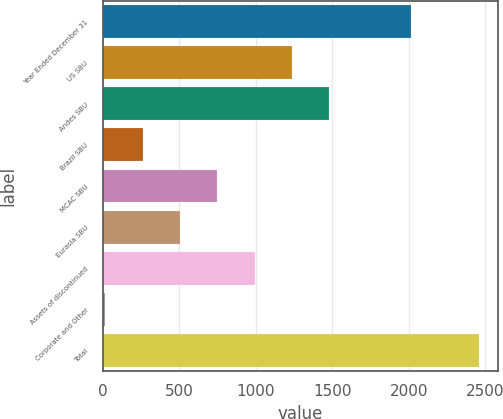Convert chart. <chart><loc_0><loc_0><loc_500><loc_500><bar_chart><fcel>Year Ended December 31<fcel>US SBU<fcel>Andes SBU<fcel>Brazil SBU<fcel>MCAC SBU<fcel>Eurasia SBU<fcel>Assets of discontinued<fcel>Corporate and Other<fcel>Total<nl><fcel>2015<fcel>1237.5<fcel>1481.6<fcel>261.1<fcel>749.3<fcel>505.2<fcel>993.4<fcel>17<fcel>2458<nl></chart> 